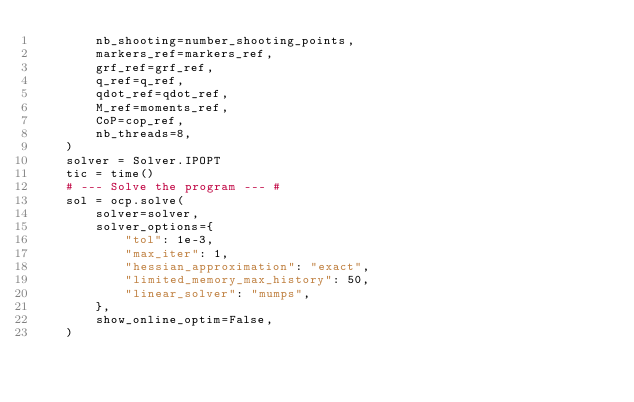Convert code to text. <code><loc_0><loc_0><loc_500><loc_500><_Python_>        nb_shooting=number_shooting_points,
        markers_ref=markers_ref,
        grf_ref=grf_ref,
        q_ref=q_ref,
        qdot_ref=qdot_ref,
        M_ref=moments_ref,
        CoP=cop_ref,
        nb_threads=8,
    )
    solver = Solver.IPOPT
    tic = time()
    # --- Solve the program --- #
    sol = ocp.solve(
        solver=solver,
        solver_options={
            "tol": 1e-3,
            "max_iter": 1,
            "hessian_approximation": "exact",
            "limited_memory_max_history": 50,
            "linear_solver": "mumps",
        },
        show_online_optim=False,
    )</code> 